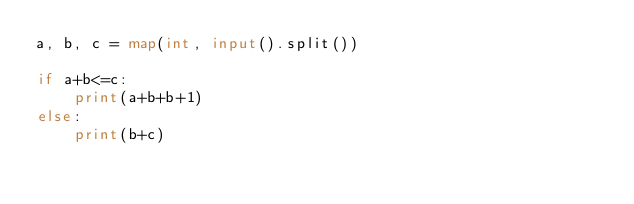<code> <loc_0><loc_0><loc_500><loc_500><_Python_>a, b, c = map(int, input().split())

if a+b<=c:
    print(a+b+b+1)
else:
    print(b+c)</code> 